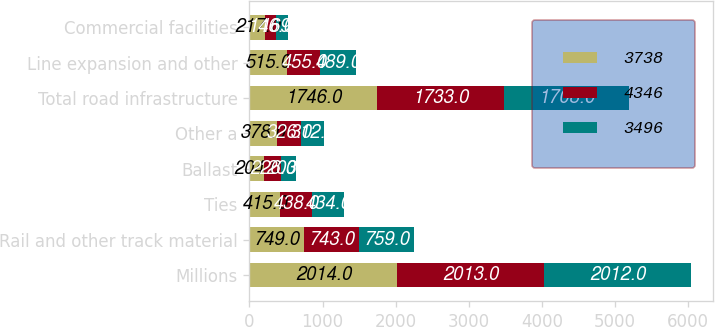Convert chart to OTSL. <chart><loc_0><loc_0><loc_500><loc_500><stacked_bar_chart><ecel><fcel>Millions<fcel>Rail and other track material<fcel>Ties<fcel>Ballast<fcel>Other a<fcel>Total road infrastructure<fcel>Line expansion and other<fcel>Commercial facilities<nl><fcel>3738<fcel>2014<fcel>749<fcel>415<fcel>204<fcel>378<fcel>1746<fcel>515<fcel>217<nl><fcel>4346<fcel>2013<fcel>743<fcel>438<fcel>226<fcel>326<fcel>1733<fcel>455<fcel>146<nl><fcel>3496<fcel>2012<fcel>759<fcel>434<fcel>203<fcel>312<fcel>1708<fcel>489<fcel>169<nl></chart> 